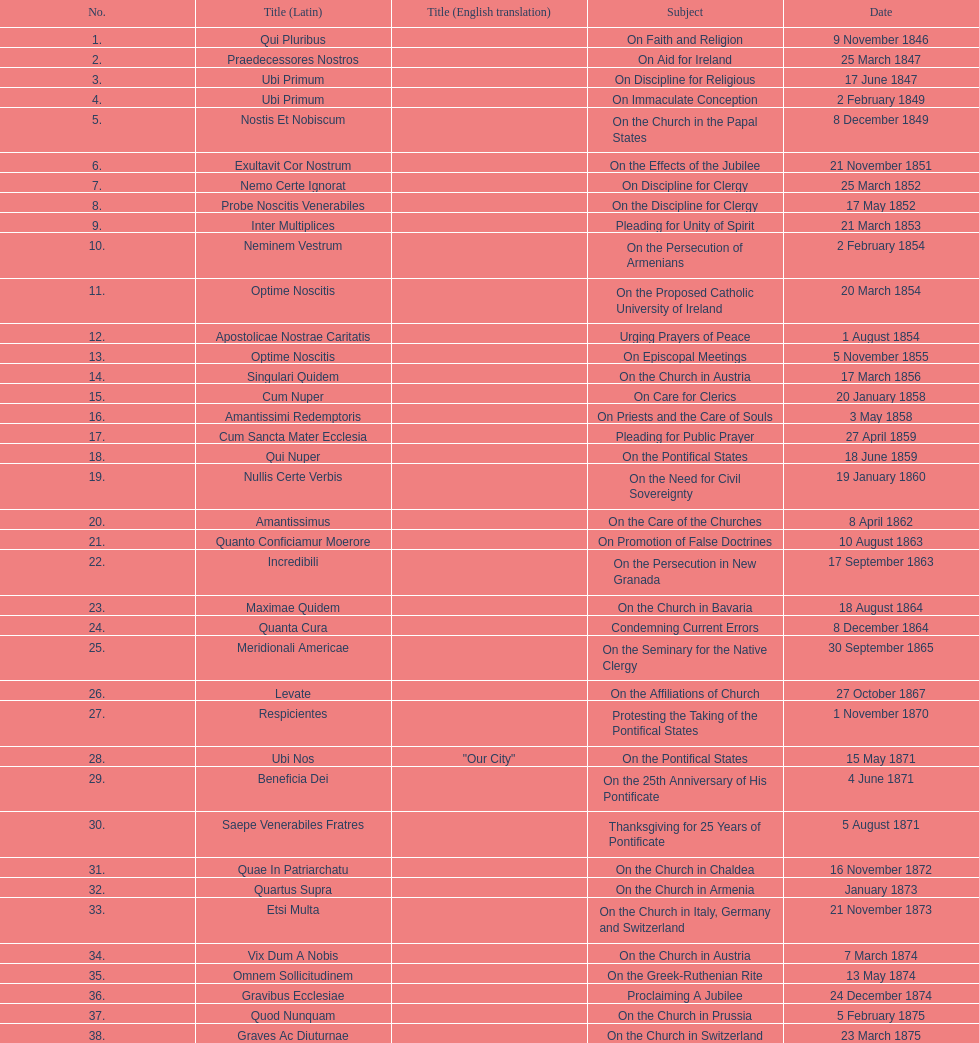What was the topic discussed prior to the effects of the jubilee? On the Church in the Papal States. 